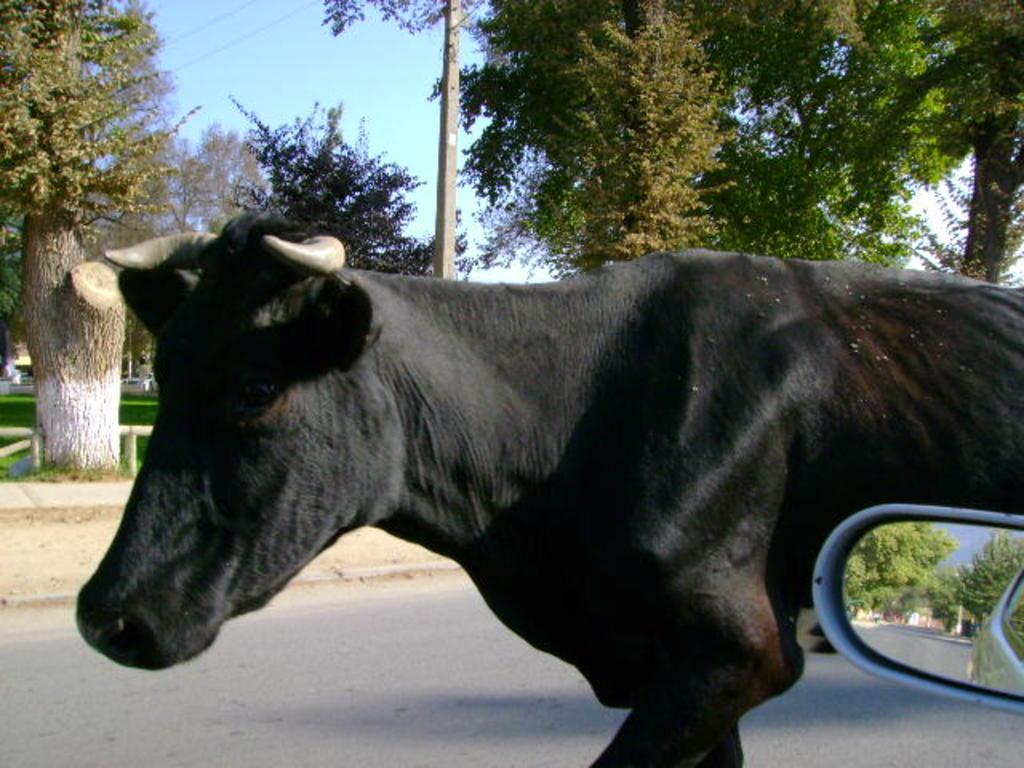Describe this image in one or two sentences. In this picture there is a black color cow walking on the road. On the bottom right corner we can see car's mirror. In the mirror we can see building, trees, sky and road. In the background we can see many trees. On the left we can see grass and wooden fencing. On the top we can see some wires. 